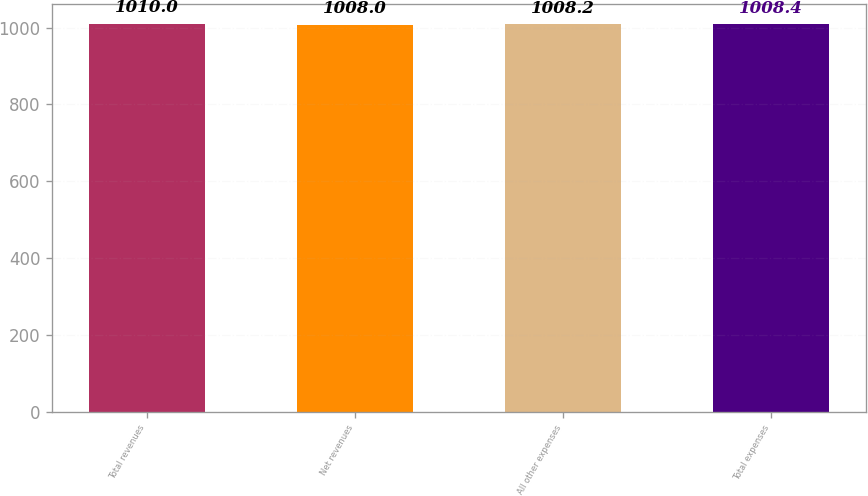Convert chart. <chart><loc_0><loc_0><loc_500><loc_500><bar_chart><fcel>Total revenues<fcel>Net revenues<fcel>All other expenses<fcel>Total expenses<nl><fcel>1010<fcel>1008<fcel>1008.2<fcel>1008.4<nl></chart> 